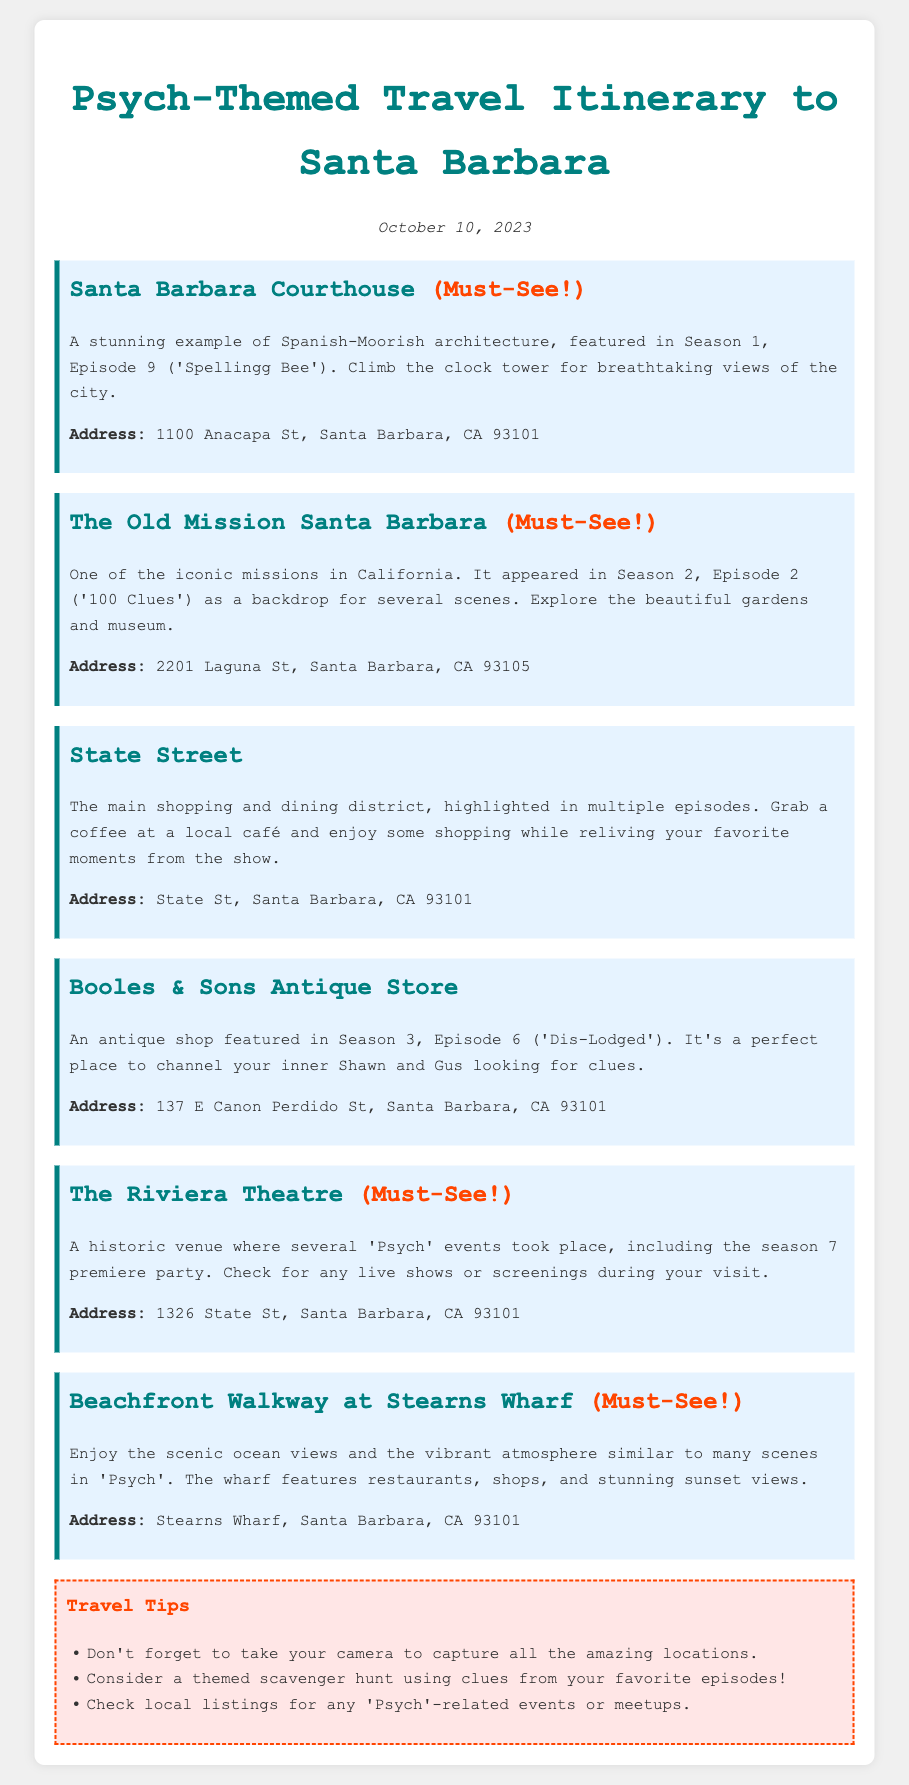What is the title of the document? The title is indicated at the top of the document, which is "Psych-Themed Travel Itinerary to Santa Barbara."
Answer: Psych-Themed Travel Itinerary to Santa Barbara What date is the itinerary for? The date is stated in the document and is "October 10, 2023."
Answer: October 10, 2023 What is the address of the Santa Barbara Courthouse? The address for the Santa Barbara Courthouse is provided in the document as "1100 Anacapa St, Santa Barbara, CA 93101."
Answer: 1100 Anacapa St, Santa Barbara, CA 93101 Which location is featured in Season 1, Episode 9? The document states that the Santa Barbara Courthouse appeared in Season 1, Episode 9 ("Spellingg Bee").
Answer: Santa Barbara Courthouse What is a unique activity suggested in the travel tips? The travel tips mention a "themed scavenger hunt using clues from your favorite episodes" as a unique activity.
Answer: Themed scavenger hunt How many must-see locations are listed in the itinerary? The number of must-see locations is indicated by counting the places that have "(Must-See!)" noted next to them in the document.
Answer: Four What architectural style is the Santa Barbara Courthouse an example of? The document describes the courthouse as an example of "Spanish-Moorish architecture."
Answer: Spanish-Moorish architecture Which theater is mentioned in relation to "Psych" events? The Riviera Theatre is mentioned as the venue where several "Psych" events took place.
Answer: Riviera Theatre What is a suggested location for coffee and shopping? The document suggests "State Street" as the main shopping and dining district for coffee and shopping.
Answer: State Street 